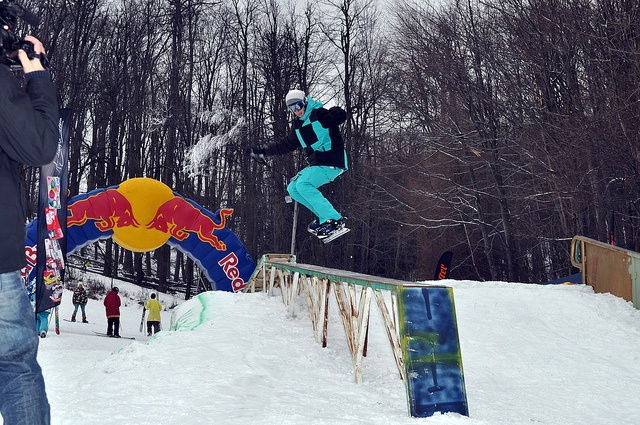Describe the objects in this image and their specific colors. I can see people in white, black, gray, and darkblue tones, people in white, black, teal, and turquoise tones, people in white, maroon, black, gray, and darkgray tones, people in white, olive, black, and lightgray tones, and people in white, black, gray, lightgray, and navy tones in this image. 